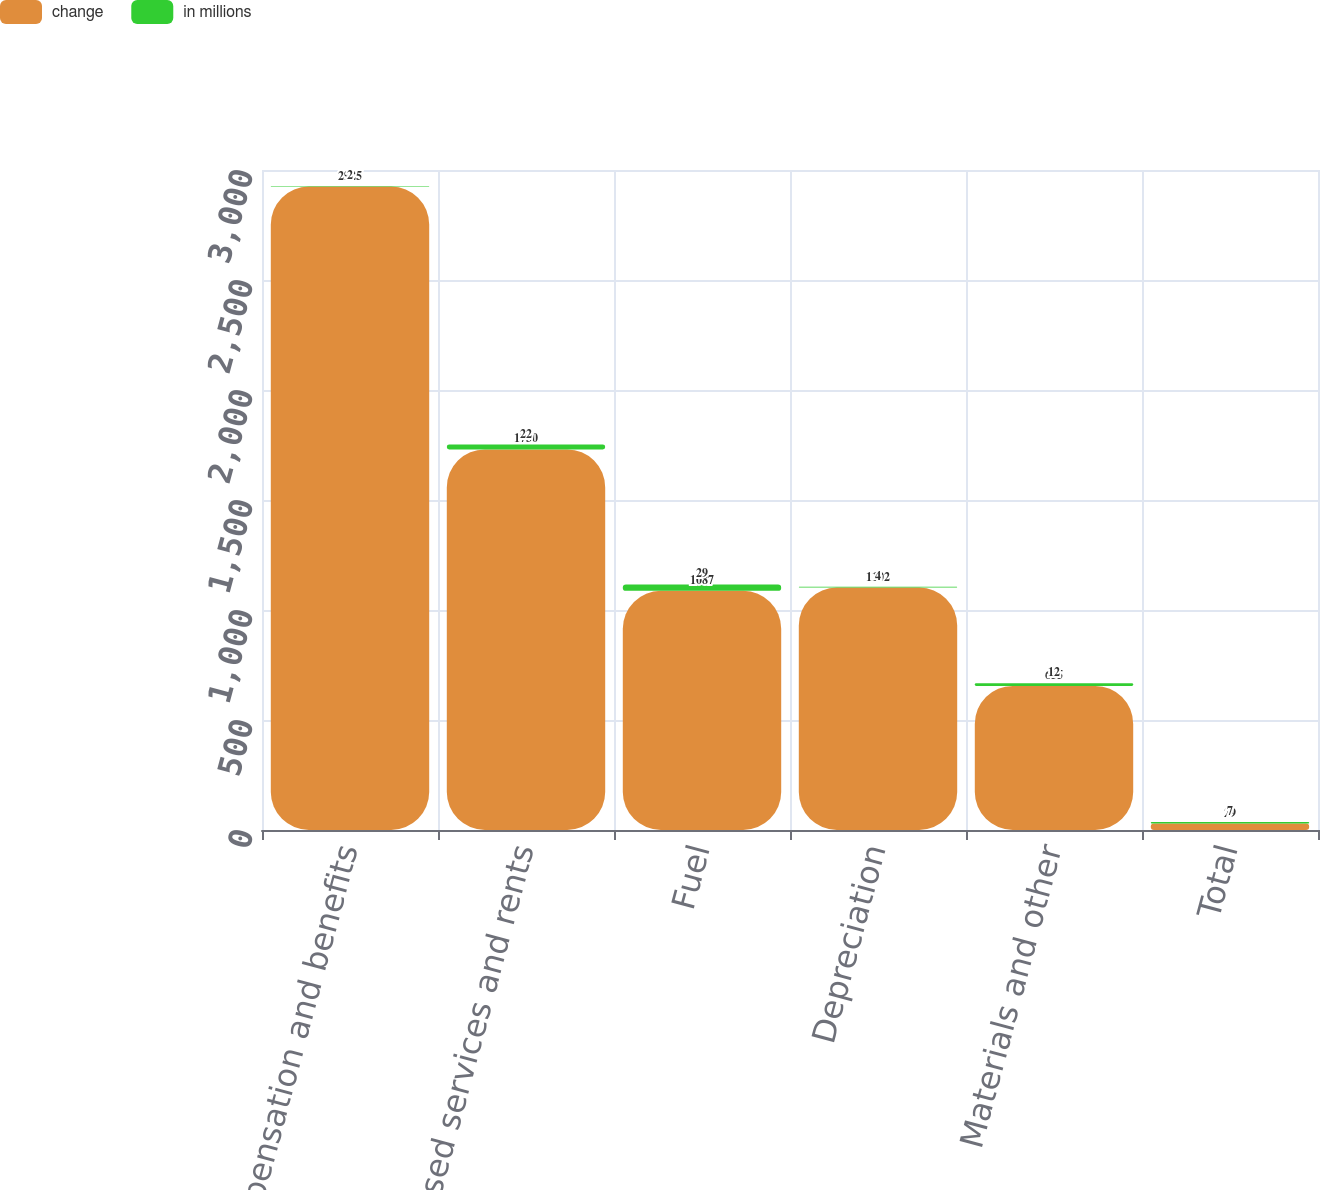Convert chart. <chart><loc_0><loc_0><loc_500><loc_500><stacked_bar_chart><ecel><fcel>Compensation and benefits<fcel>Purchased services and rents<fcel>Fuel<fcel>Depreciation<fcel>Materials and other<fcel>Total<nl><fcel>change<fcel>2925<fcel>1730<fcel>1087<fcel>1102<fcel>655<fcel>29<nl><fcel>in millions<fcel>2<fcel>22<fcel>29<fcel>4<fcel>12<fcel>7<nl></chart> 